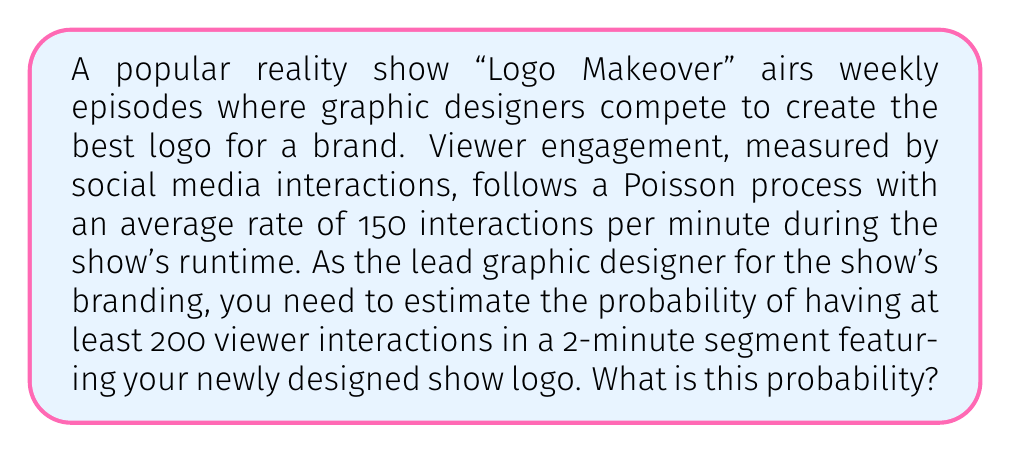What is the answer to this math problem? Let's approach this step-by-step:

1) We're dealing with a Poisson process where:
   - The rate (λ) is 150 interactions per minute
   - We're interested in a 2-minute interval
   - We want to find P(X ≥ 200), where X is the number of interactions

2) For a 2-minute interval, the Poisson parameter becomes:
   $$λ_2 = 150 * 2 = 300$$

3) We need to find P(X ≥ 200). It's often easier to calculate this as:
   $$P(X ≥ 200) = 1 - P(X < 200) = 1 - P(X ≤ 199)$$

4) The cumulative distribution function (CDF) of a Poisson distribution is given by:
   $$P(X ≤ k) = e^{-λ} \sum_{i=0}^k \frac{λ^i}{i!}$$

5) Therefore, we need to calculate:
   $$1 - e^{-300} \sum_{i=0}^{199} \frac{300^i}{i!}$$

6) This calculation is complex to do by hand, so we typically use statistical software or tables. Using such a tool, we find:

   $$P(X ≤ 199) ≈ 0.0281$$

7) Thus, the probability we're looking for is:
   $$P(X ≥ 200) = 1 - 0.0281 = 0.9719$$
Answer: 0.9719 